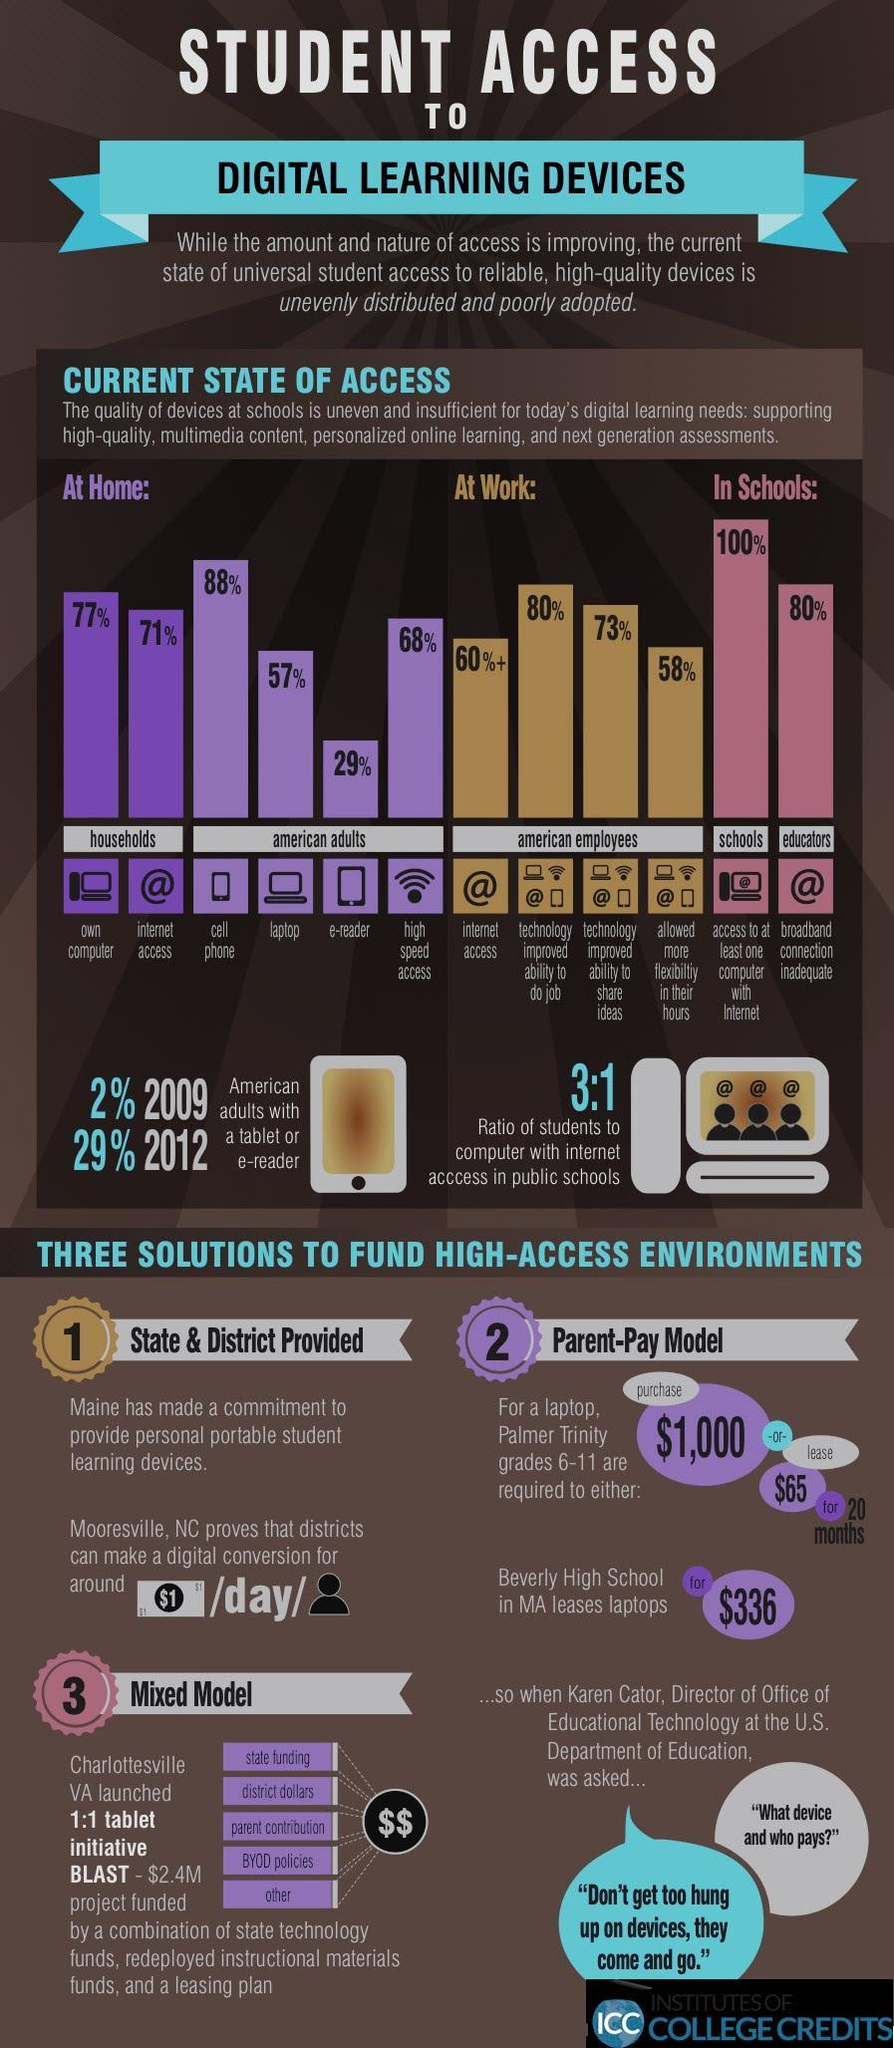What percentage of the American adults have a cellphone at home?
Answer the question with a short phrase. 88% What percentage of American adults do not own a tablet or e-reader in 2012? 71% What percentage of American schools have access to at least one computer with internet? 100% What percentage of American adults do not own a tablet or e-reader in 2009? 98% What percentage of households in America own a computer? 77% What percentage of the American adults have access to high speed WiFi at home? 68% What percentage of the educators in America are having inadequate broadband connection? 80% What percent of the American employees have access to the internet? 60%+ What percentage of households in America have internet access? 71% 